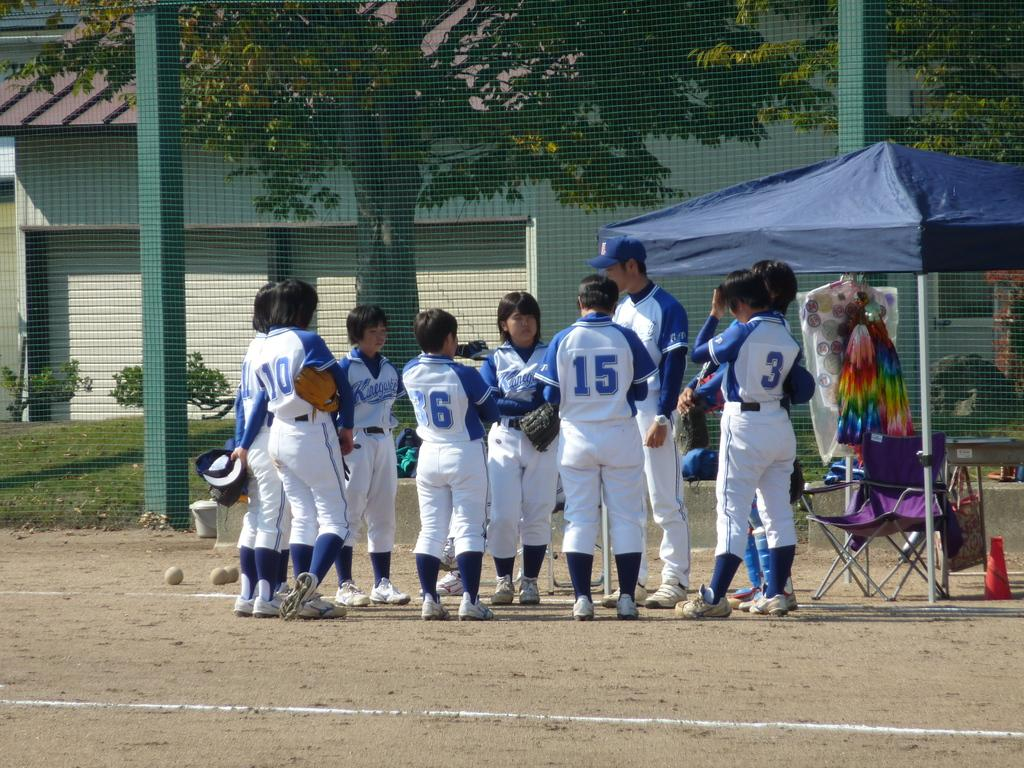<image>
Create a compact narrative representing the image presented. A group of baseball players that number 15 is apart of 